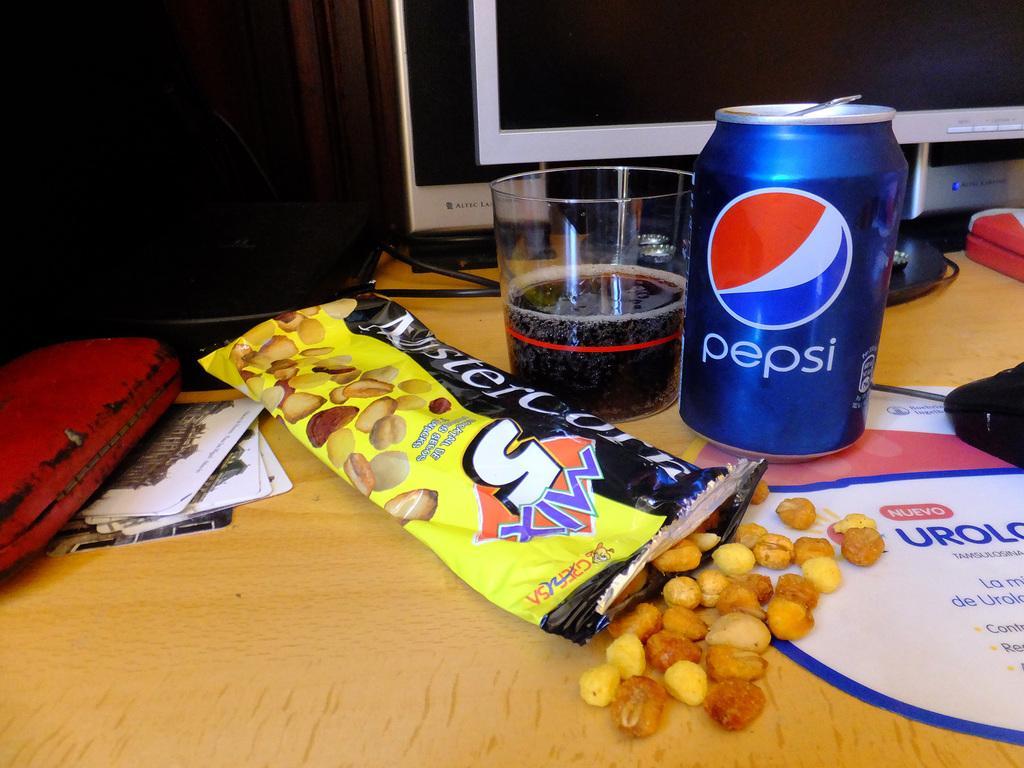Describe this image in one or two sentences. In this image I can see the food, tin and the glass on the table and I can also see the system and few objects. 